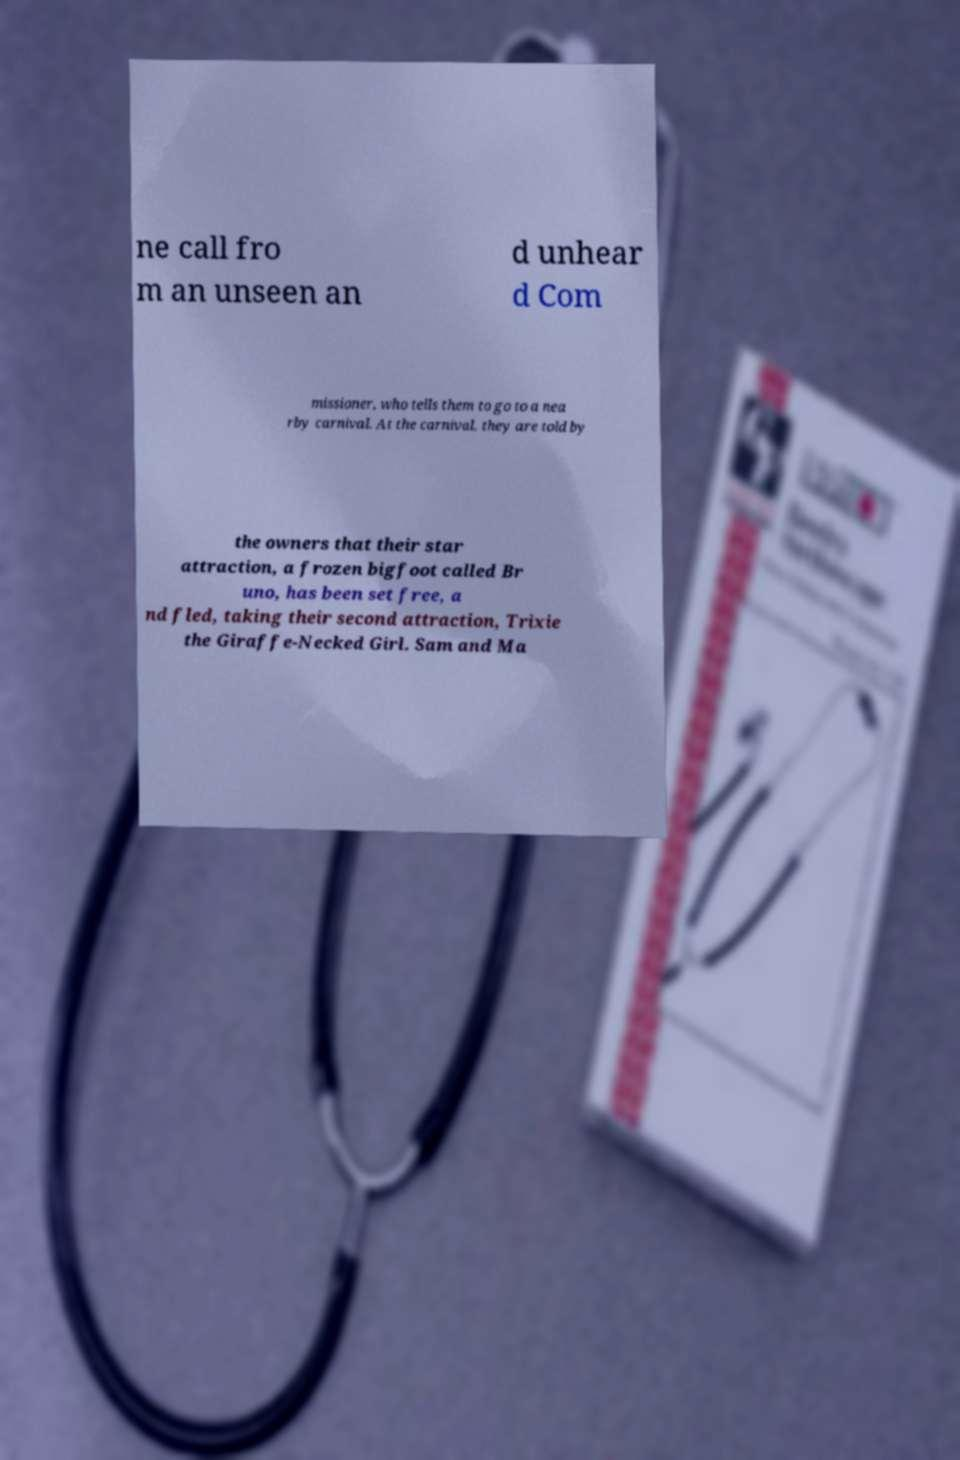Can you read and provide the text displayed in the image?This photo seems to have some interesting text. Can you extract and type it out for me? ne call fro m an unseen an d unhear d Com missioner, who tells them to go to a nea rby carnival. At the carnival, they are told by the owners that their star attraction, a frozen bigfoot called Br uno, has been set free, a nd fled, taking their second attraction, Trixie the Giraffe-Necked Girl. Sam and Ma 